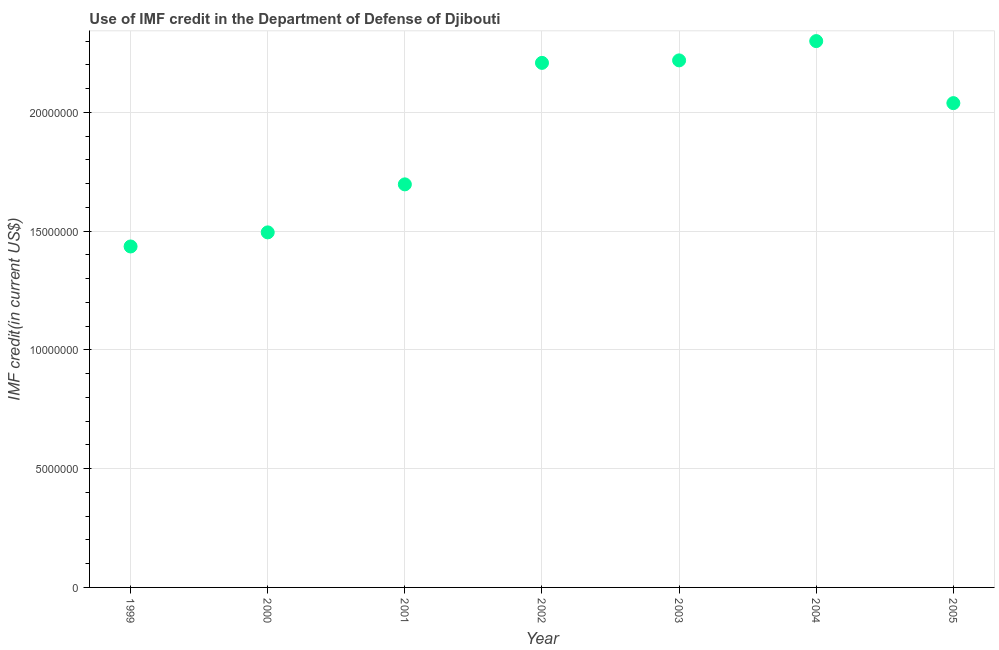What is the use of imf credit in dod in 2005?
Offer a terse response. 2.04e+07. Across all years, what is the maximum use of imf credit in dod?
Your answer should be very brief. 2.30e+07. Across all years, what is the minimum use of imf credit in dod?
Provide a short and direct response. 1.44e+07. What is the sum of the use of imf credit in dod?
Your answer should be compact. 1.34e+08. What is the difference between the use of imf credit in dod in 1999 and 2004?
Keep it short and to the point. -8.64e+06. What is the average use of imf credit in dod per year?
Give a very brief answer. 1.91e+07. What is the median use of imf credit in dod?
Offer a very short reply. 2.04e+07. In how many years, is the use of imf credit in dod greater than 18000000 US$?
Provide a succinct answer. 4. Do a majority of the years between 2004 and 1999 (inclusive) have use of imf credit in dod greater than 12000000 US$?
Give a very brief answer. Yes. What is the ratio of the use of imf credit in dod in 2000 to that in 2003?
Your answer should be compact. 0.67. Is the use of imf credit in dod in 2002 less than that in 2004?
Your answer should be compact. Yes. What is the difference between the highest and the second highest use of imf credit in dod?
Your answer should be compact. 8.12e+05. Is the sum of the use of imf credit in dod in 2002 and 2005 greater than the maximum use of imf credit in dod across all years?
Make the answer very short. Yes. What is the difference between the highest and the lowest use of imf credit in dod?
Your answer should be very brief. 8.64e+06. In how many years, is the use of imf credit in dod greater than the average use of imf credit in dod taken over all years?
Keep it short and to the point. 4. Does the use of imf credit in dod monotonically increase over the years?
Make the answer very short. No. How many dotlines are there?
Provide a short and direct response. 1. How many years are there in the graph?
Offer a very short reply. 7. What is the difference between two consecutive major ticks on the Y-axis?
Offer a terse response. 5.00e+06. Does the graph contain any zero values?
Your response must be concise. No. What is the title of the graph?
Ensure brevity in your answer.  Use of IMF credit in the Department of Defense of Djibouti. What is the label or title of the Y-axis?
Offer a very short reply. IMF credit(in current US$). What is the IMF credit(in current US$) in 1999?
Offer a very short reply. 1.44e+07. What is the IMF credit(in current US$) in 2000?
Provide a short and direct response. 1.49e+07. What is the IMF credit(in current US$) in 2001?
Offer a terse response. 1.70e+07. What is the IMF credit(in current US$) in 2002?
Keep it short and to the point. 2.21e+07. What is the IMF credit(in current US$) in 2003?
Give a very brief answer. 2.22e+07. What is the IMF credit(in current US$) in 2004?
Give a very brief answer. 2.30e+07. What is the IMF credit(in current US$) in 2005?
Make the answer very short. 2.04e+07. What is the difference between the IMF credit(in current US$) in 1999 and 2000?
Make the answer very short. -5.93e+05. What is the difference between the IMF credit(in current US$) in 1999 and 2001?
Your answer should be very brief. -2.61e+06. What is the difference between the IMF credit(in current US$) in 1999 and 2002?
Make the answer very short. -7.73e+06. What is the difference between the IMF credit(in current US$) in 1999 and 2003?
Make the answer very short. -7.83e+06. What is the difference between the IMF credit(in current US$) in 1999 and 2004?
Offer a terse response. -8.64e+06. What is the difference between the IMF credit(in current US$) in 1999 and 2005?
Ensure brevity in your answer.  -6.03e+06. What is the difference between the IMF credit(in current US$) in 2000 and 2001?
Offer a terse response. -2.02e+06. What is the difference between the IMF credit(in current US$) in 2000 and 2002?
Provide a succinct answer. -7.14e+06. What is the difference between the IMF credit(in current US$) in 2000 and 2003?
Offer a very short reply. -7.24e+06. What is the difference between the IMF credit(in current US$) in 2000 and 2004?
Make the answer very short. -8.05e+06. What is the difference between the IMF credit(in current US$) in 2000 and 2005?
Provide a short and direct response. -5.44e+06. What is the difference between the IMF credit(in current US$) in 2001 and 2002?
Your answer should be very brief. -5.11e+06. What is the difference between the IMF credit(in current US$) in 2001 and 2003?
Ensure brevity in your answer.  -5.22e+06. What is the difference between the IMF credit(in current US$) in 2001 and 2004?
Offer a terse response. -6.03e+06. What is the difference between the IMF credit(in current US$) in 2001 and 2005?
Your answer should be compact. -3.42e+06. What is the difference between the IMF credit(in current US$) in 2002 and 2003?
Keep it short and to the point. -1.05e+05. What is the difference between the IMF credit(in current US$) in 2002 and 2004?
Your answer should be very brief. -9.17e+05. What is the difference between the IMF credit(in current US$) in 2002 and 2005?
Make the answer very short. 1.69e+06. What is the difference between the IMF credit(in current US$) in 2003 and 2004?
Ensure brevity in your answer.  -8.12e+05. What is the difference between the IMF credit(in current US$) in 2003 and 2005?
Ensure brevity in your answer.  1.80e+06. What is the difference between the IMF credit(in current US$) in 2004 and 2005?
Your response must be concise. 2.61e+06. What is the ratio of the IMF credit(in current US$) in 1999 to that in 2001?
Ensure brevity in your answer.  0.85. What is the ratio of the IMF credit(in current US$) in 1999 to that in 2002?
Provide a short and direct response. 0.65. What is the ratio of the IMF credit(in current US$) in 1999 to that in 2003?
Provide a succinct answer. 0.65. What is the ratio of the IMF credit(in current US$) in 1999 to that in 2004?
Make the answer very short. 0.62. What is the ratio of the IMF credit(in current US$) in 1999 to that in 2005?
Provide a succinct answer. 0.7. What is the ratio of the IMF credit(in current US$) in 2000 to that in 2001?
Offer a terse response. 0.88. What is the ratio of the IMF credit(in current US$) in 2000 to that in 2002?
Your response must be concise. 0.68. What is the ratio of the IMF credit(in current US$) in 2000 to that in 2003?
Give a very brief answer. 0.67. What is the ratio of the IMF credit(in current US$) in 2000 to that in 2004?
Offer a terse response. 0.65. What is the ratio of the IMF credit(in current US$) in 2000 to that in 2005?
Provide a short and direct response. 0.73. What is the ratio of the IMF credit(in current US$) in 2001 to that in 2002?
Make the answer very short. 0.77. What is the ratio of the IMF credit(in current US$) in 2001 to that in 2003?
Give a very brief answer. 0.77. What is the ratio of the IMF credit(in current US$) in 2001 to that in 2004?
Provide a succinct answer. 0.74. What is the ratio of the IMF credit(in current US$) in 2001 to that in 2005?
Ensure brevity in your answer.  0.83. What is the ratio of the IMF credit(in current US$) in 2002 to that in 2003?
Ensure brevity in your answer.  0.99. What is the ratio of the IMF credit(in current US$) in 2002 to that in 2004?
Offer a very short reply. 0.96. What is the ratio of the IMF credit(in current US$) in 2002 to that in 2005?
Offer a very short reply. 1.08. What is the ratio of the IMF credit(in current US$) in 2003 to that in 2005?
Provide a short and direct response. 1.09. What is the ratio of the IMF credit(in current US$) in 2004 to that in 2005?
Keep it short and to the point. 1.13. 